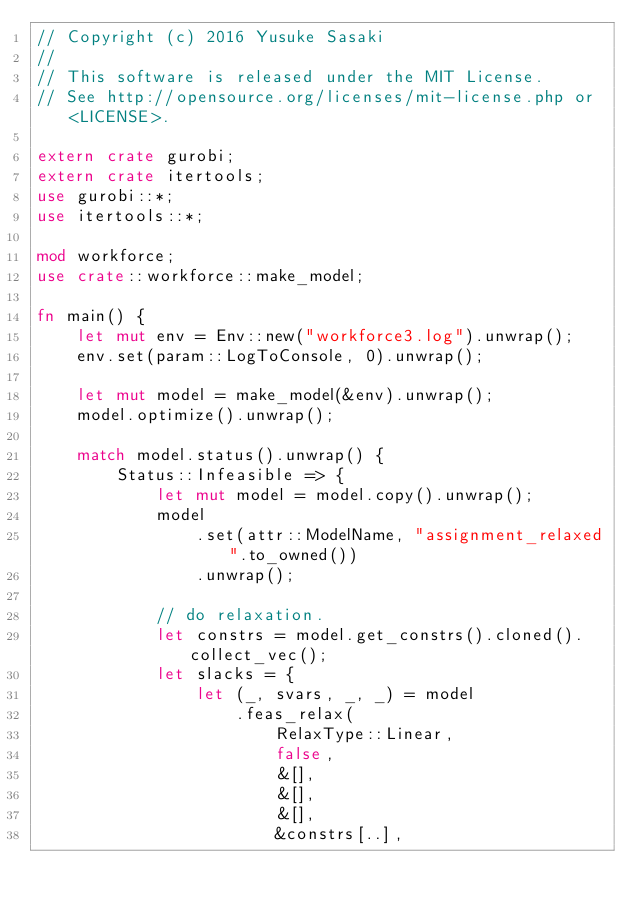Convert code to text. <code><loc_0><loc_0><loc_500><loc_500><_Rust_>// Copyright (c) 2016 Yusuke Sasaki
//
// This software is released under the MIT License.
// See http://opensource.org/licenses/mit-license.php or <LICENSE>.

extern crate gurobi;
extern crate itertools;
use gurobi::*;
use itertools::*;

mod workforce;
use crate::workforce::make_model;

fn main() {
    let mut env = Env::new("workforce3.log").unwrap();
    env.set(param::LogToConsole, 0).unwrap();

    let mut model = make_model(&env).unwrap();
    model.optimize().unwrap();

    match model.status().unwrap() {
        Status::Infeasible => {
            let mut model = model.copy().unwrap();
            model
                .set(attr::ModelName, "assignment_relaxed".to_owned())
                .unwrap();

            // do relaxation.
            let constrs = model.get_constrs().cloned().collect_vec();
            let slacks = {
                let (_, svars, _, _) = model
                    .feas_relax(
                        RelaxType::Linear,
                        false,
                        &[],
                        &[],
                        &[],
                        &constrs[..],</code> 